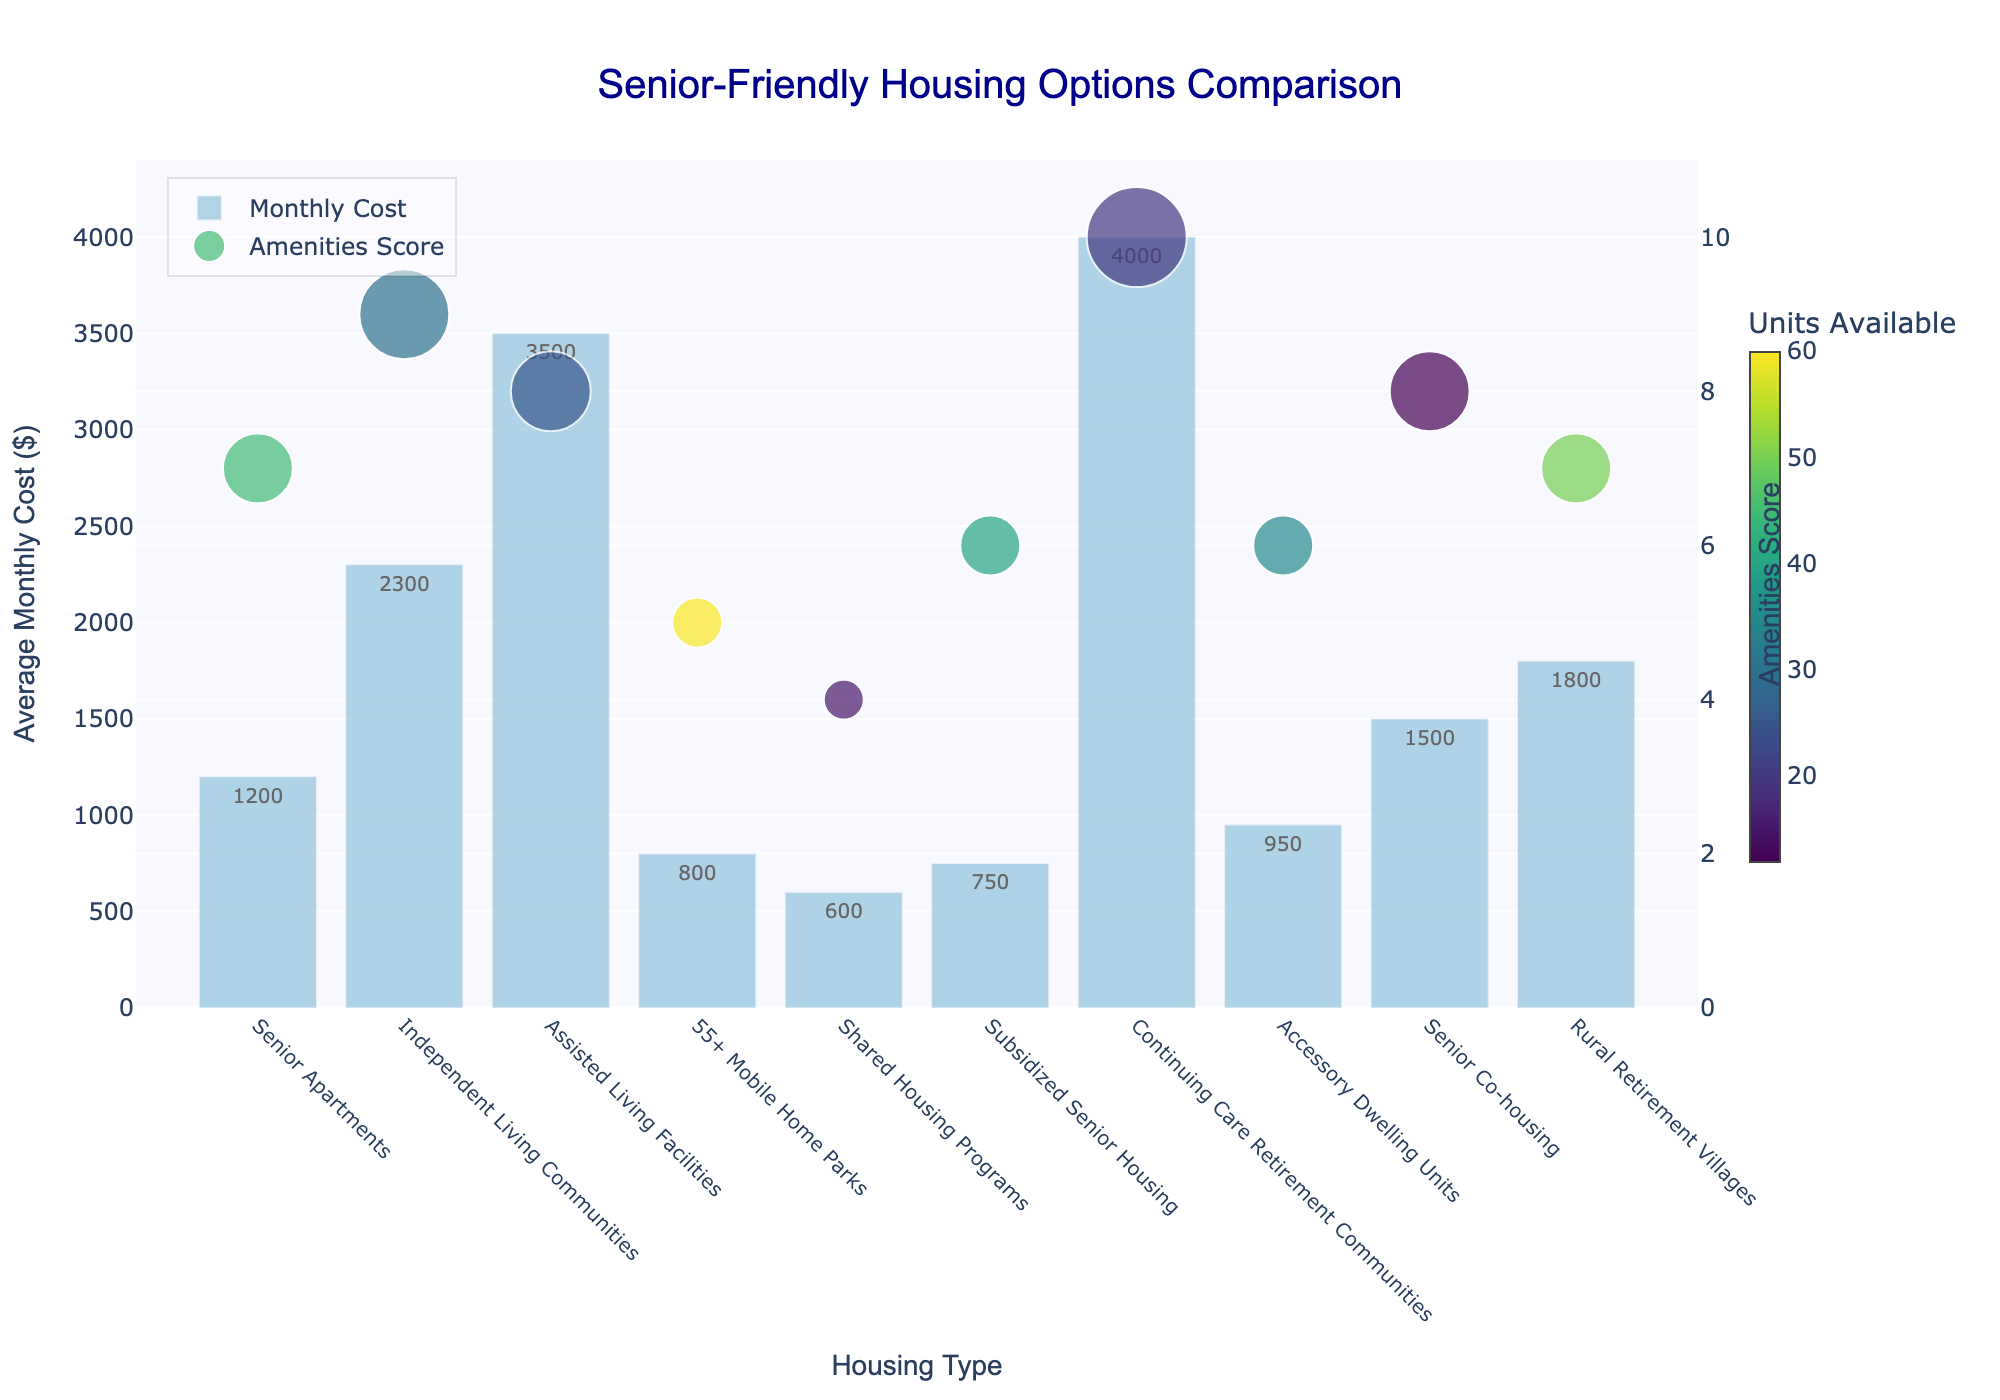What is the housing type with the lowest average monthly cost? The bar representing "Shared Housing Programs" is the shortest, indicating the lowest cost.
Answer: Shared Housing Programs Which housing type has the highest amenities score and how many units are available in that category? The dot representing "Continuing Care Retirement Communities" is the highest on the amenities score axis and larger in size, and the color bar indicates the exact number of units is 20.
Answer: Continuing Care Retirement Communities, 20 units How do the monthly costs of Senior Apartments and Independent Living Communities compare? The bar for "Independent Living Communities" is higher than the bar for "Senior Apartments". The costs are $2300 and $1200 respectively.
Answer: Independent Living Communities are more expensive by $1100 Which housing options offer an amenities score of 6, and what are their monthly costs? The dots representing "Subsidized Senior Housing" and "Accessory Dwelling Units" are aligned with the amenities score of 6. Their bars indicate monthly costs of $750 and $950 respectively.
Answer: Subsidized Senior Housing ($750) and Accessory Dwelling Units ($950) What is the difference in average monthly cost between Assisted Living Facilities and 55+ Mobile Home Parks? The bar for "Assisted Living Facilities" is higher than for "55+ Mobile Home Parks". Their costs are $3500 and $800 respectively. The difference is $3500 - $800 = $2700.
Answer: $2700 How does the amenities score of Senior Co-housing compare to that of Rural Retirement Villages? The dot for "Senior Co-housing" is slightly higher than the dot for "Rural Retirement Villages", indicating a score of 8 compared to 7.
Answer: Senior Co-housing is higher by 1 point What is the combined number of units available for Senior Apartments and Rural Retirement Villages? The unit sizes indicated by the dots and the color key show 45 units for Senior Apartments and 50 for Rural Retirement Villages. Summing them gives 45 + 50 = 95 units.
Answer: 95 units Which two housing types have the greatest difference in the average monthly cost and what is that difference? "Continuing Care Retirement Communities" has the highest bar at $4000 and "Shared Housing Programs" has the lowest bar at $600. The difference is $4000 - $600 = $3400.
Answer: Continuing Care Retirement Communities and Shared Housing Programs, $3400 What color represents the number of units available for 55+ Mobile Home Parks and what does it indicate? The color of the dot for "55+ Mobile Home Parks" matches the color scale used in the figure, which aligns with 60 units.
Answer: A color indicating 60 units How does the amenities score of Accessory Dwelling Units compare with that of Subsidized Senior Housing and what are their respective average monthly costs? Both "Accessory Dwelling Units" and "Subsidized Senior Housing" have dots aligned with an amenities score of 6. The bars show their monthly costs as $950 and $750 respectively.
Answer: Both have an amenities score of 6; Accessory Dwelling Units cost $950, Subsidized Senior Housing costs $750 